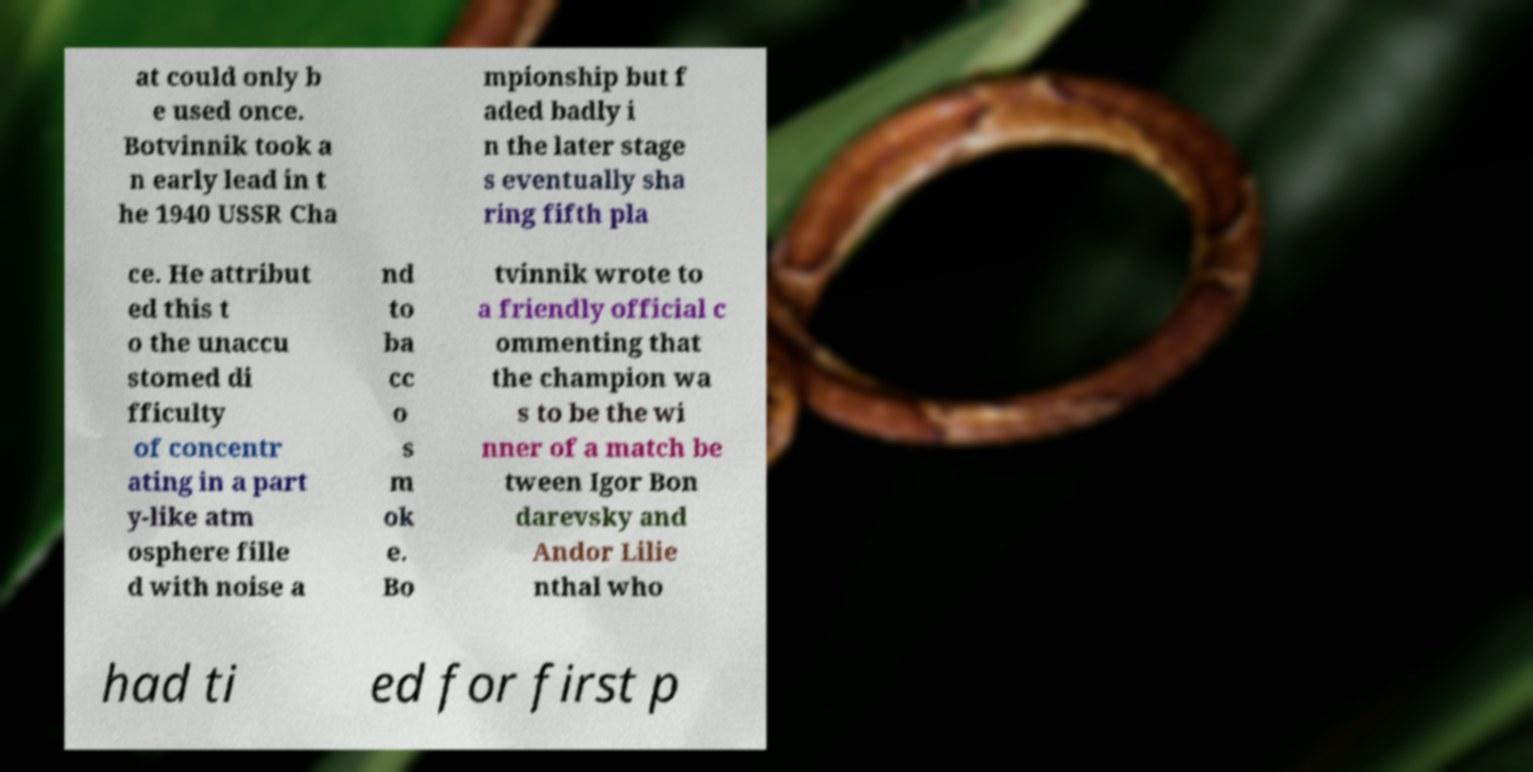For documentation purposes, I need the text within this image transcribed. Could you provide that? at could only b e used once. Botvinnik took a n early lead in t he 1940 USSR Cha mpionship but f aded badly i n the later stage s eventually sha ring fifth pla ce. He attribut ed this t o the unaccu stomed di fficulty of concentr ating in a part y-like atm osphere fille d with noise a nd to ba cc o s m ok e. Bo tvinnik wrote to a friendly official c ommenting that the champion wa s to be the wi nner of a match be tween Igor Bon darevsky and Andor Lilie nthal who had ti ed for first p 